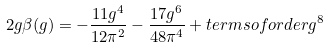<formula> <loc_0><loc_0><loc_500><loc_500>2 g \beta ( g ) = - \frac { 1 1 g ^ { 4 } } { 1 2 \pi ^ { 2 } } - \frac { 1 7 g ^ { 6 } } { 4 8 \pi ^ { 4 } } + t e r m s o f o r d e r g ^ { 8 }</formula> 